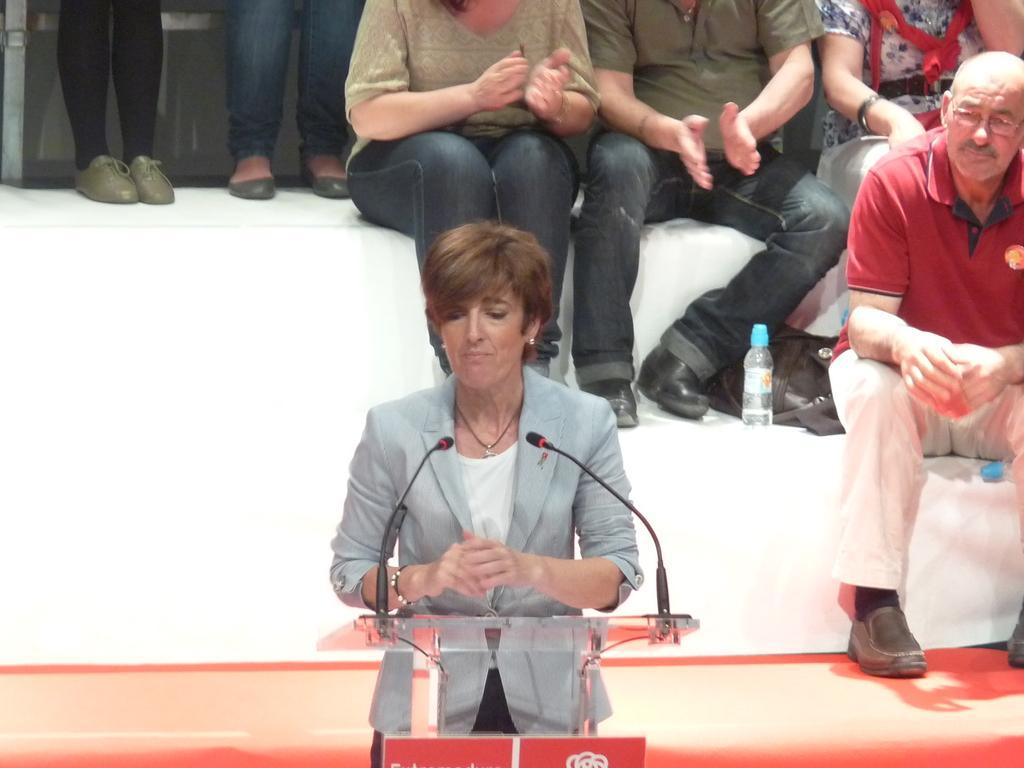Could you give a brief overview of what you see in this image? In this picture we can see a woman is standing behind the podium and on the podium there are microphones with stands. Behind the women there are groups of people sitting, bottle and a bag. 